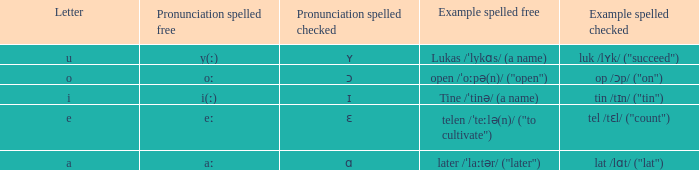What is Pronunciation Spelled Checked, when Example Spelled Checked is "tin /tɪn/ ("tin")" Ɪ. 